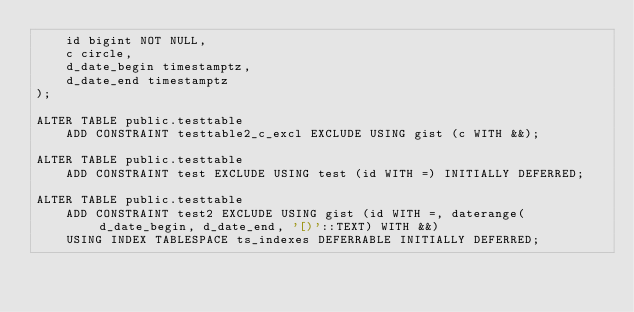<code> <loc_0><loc_0><loc_500><loc_500><_SQL_>    id bigint NOT NULL,
    c circle,
    d_date_begin timestamptz,
    d_date_end timestamptz
);

ALTER TABLE public.testtable
    ADD CONSTRAINT testtable2_c_excl EXCLUDE USING gist (c WITH &&);

ALTER TABLE public.testtable
    ADD CONSTRAINT test EXCLUDE USING test (id WITH =) INITIALLY DEFERRED;

ALTER TABLE public.testtable
    ADD CONSTRAINT test2 EXCLUDE USING gist (id WITH =, daterange(d_date_begin, d_date_end, '[)'::TEXT) WITH &&)
    USING INDEX TABLESPACE ts_indexes DEFERRABLE INITIALLY DEFERRED;</code> 